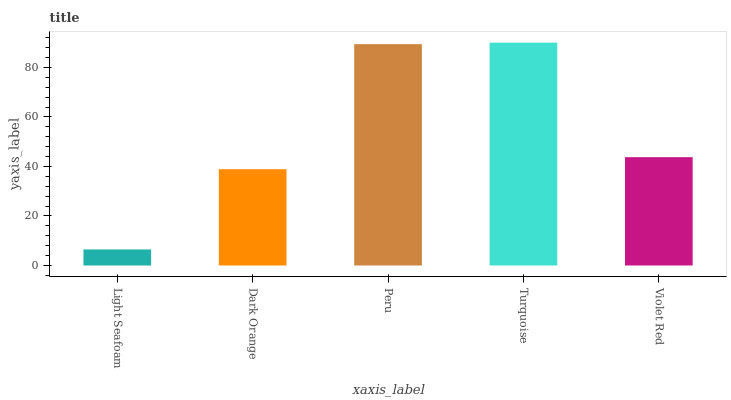Is Dark Orange the minimum?
Answer yes or no. No. Is Dark Orange the maximum?
Answer yes or no. No. Is Dark Orange greater than Light Seafoam?
Answer yes or no. Yes. Is Light Seafoam less than Dark Orange?
Answer yes or no. Yes. Is Light Seafoam greater than Dark Orange?
Answer yes or no. No. Is Dark Orange less than Light Seafoam?
Answer yes or no. No. Is Violet Red the high median?
Answer yes or no. Yes. Is Violet Red the low median?
Answer yes or no. Yes. Is Light Seafoam the high median?
Answer yes or no. No. Is Light Seafoam the low median?
Answer yes or no. No. 